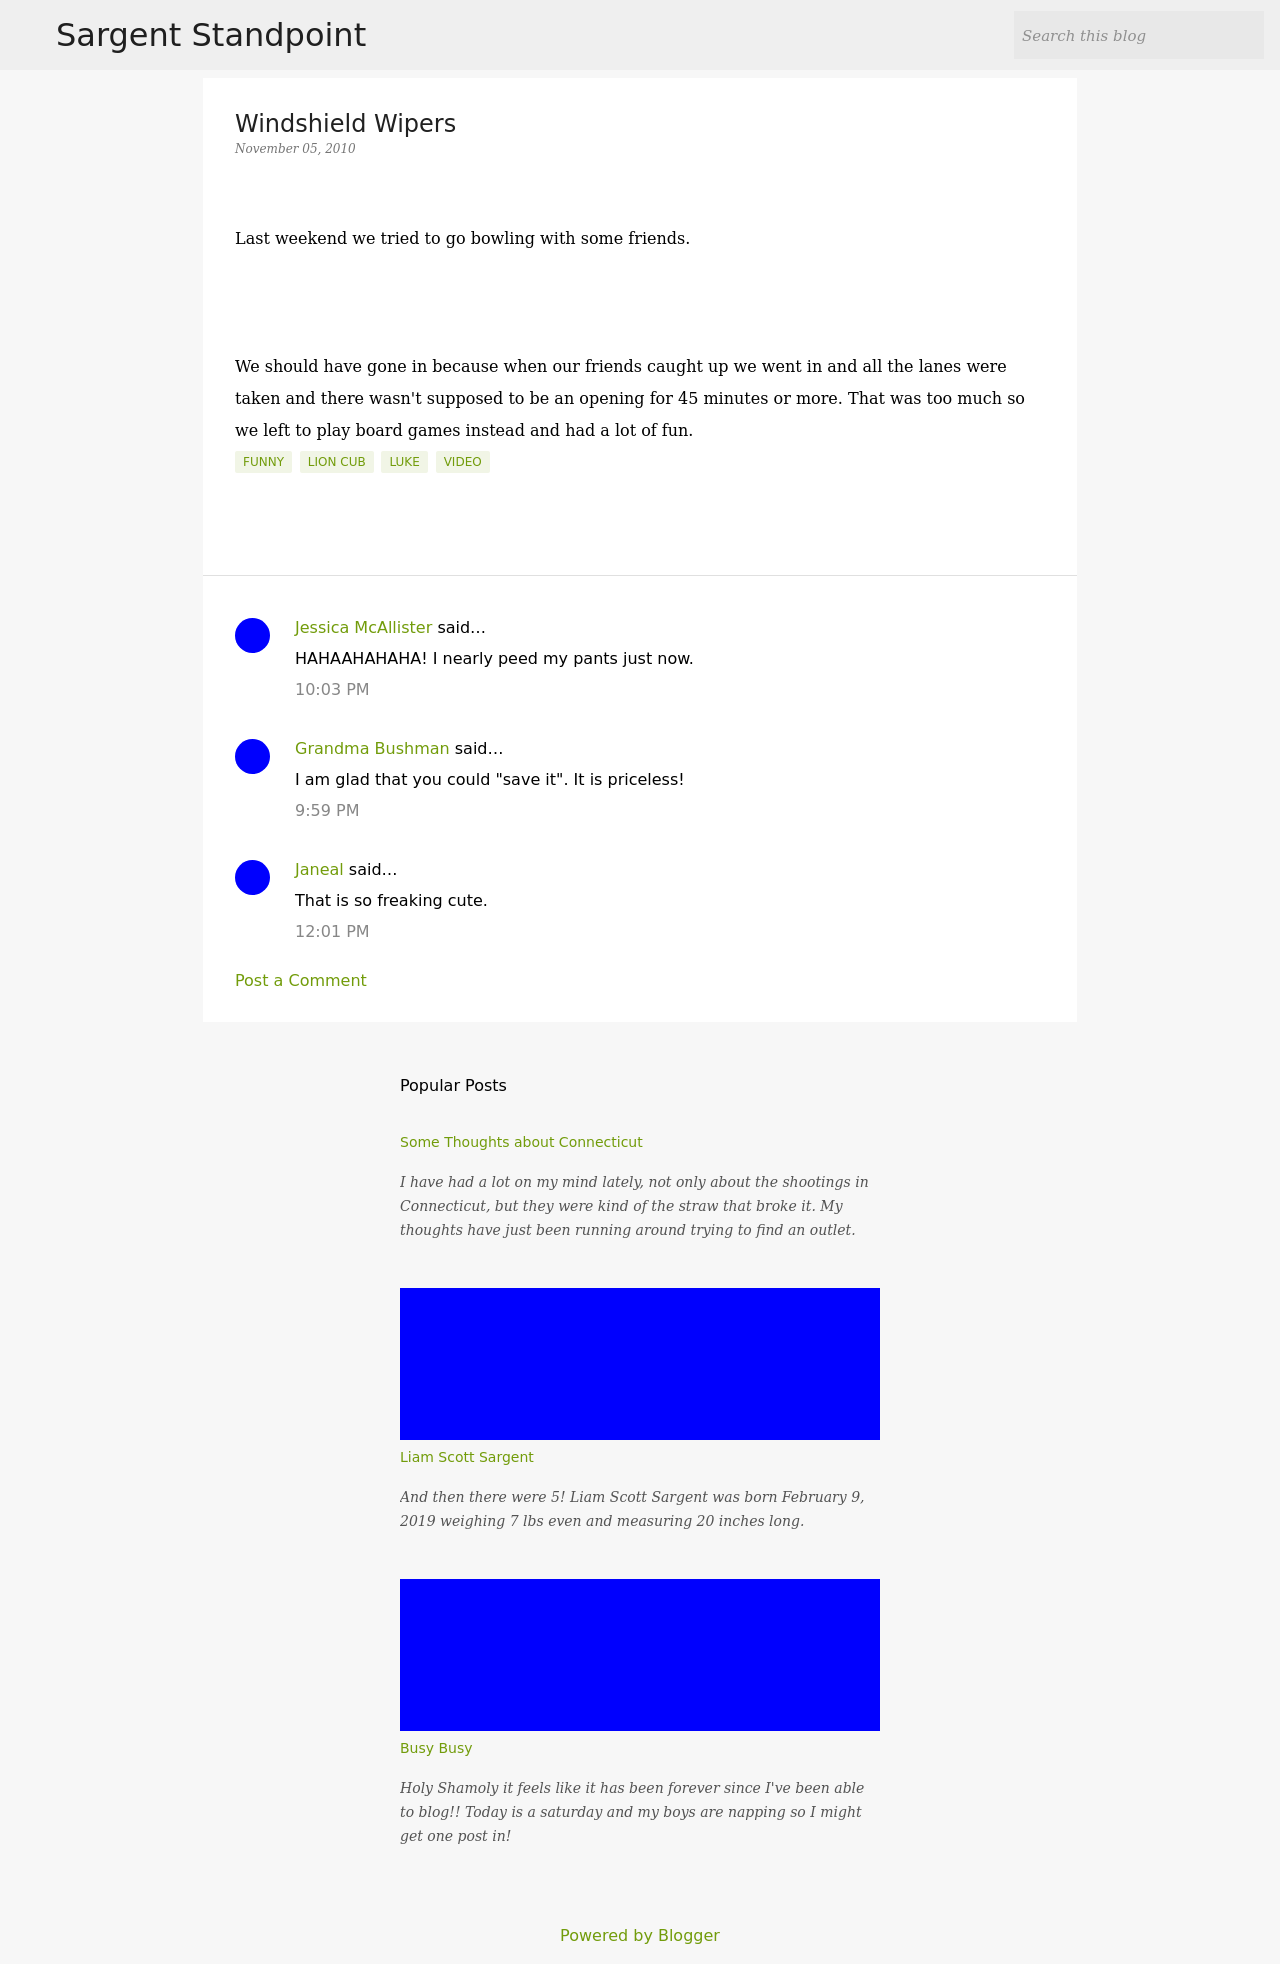How does the design of the blog interface support the content? The blog interface uses a clean and straightforward design that allows easy reading and navigation. The use of clear headers and dedicated sections for comments and popular posts helps users engage more efficiently with the content. Additionally, the visual design is minimalistic, ensuring that the text and user interactions remain the focus. 